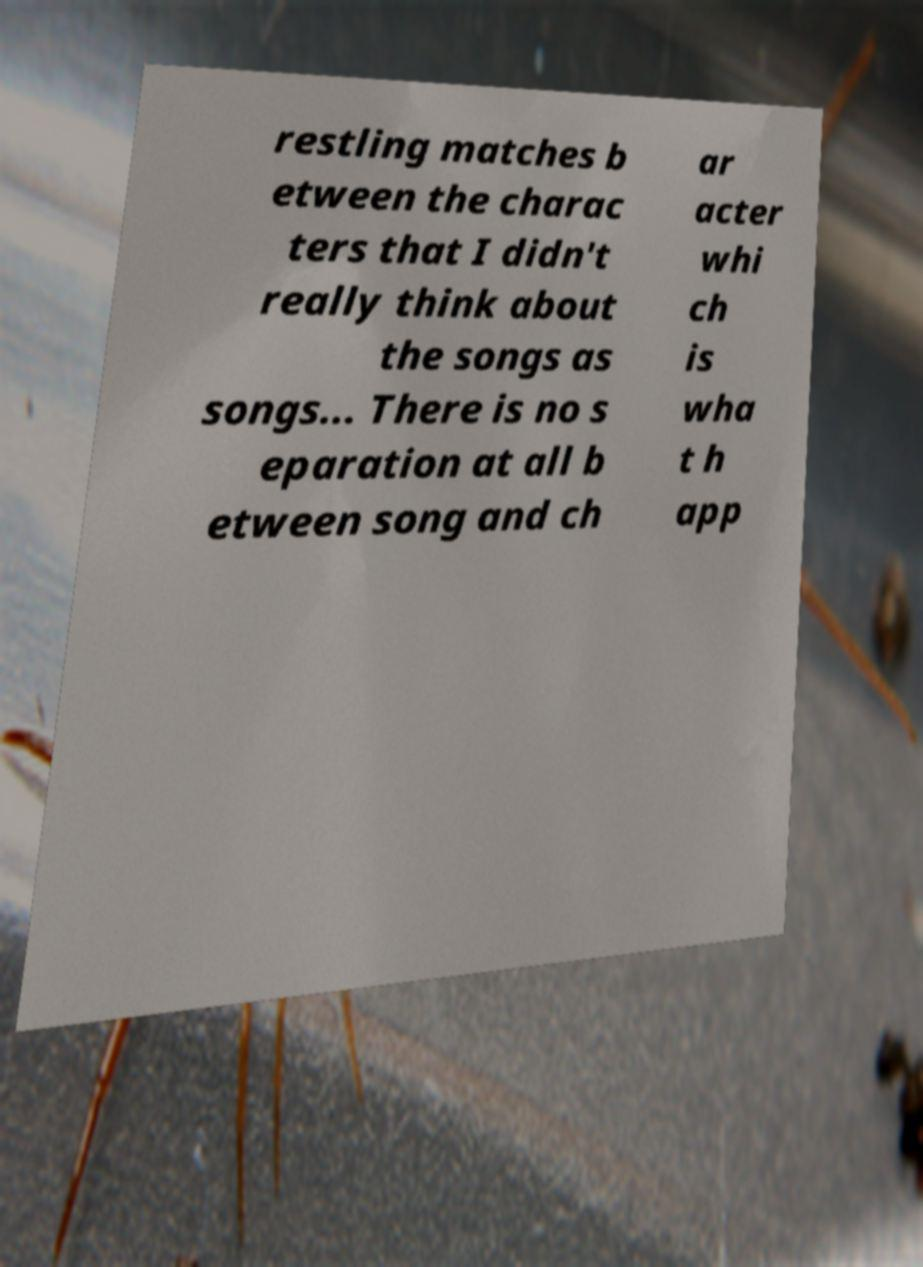Can you accurately transcribe the text from the provided image for me? restling matches b etween the charac ters that I didn't really think about the songs as songs... There is no s eparation at all b etween song and ch ar acter whi ch is wha t h app 